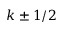<formula> <loc_0><loc_0><loc_500><loc_500>k \pm 1 / 2</formula> 